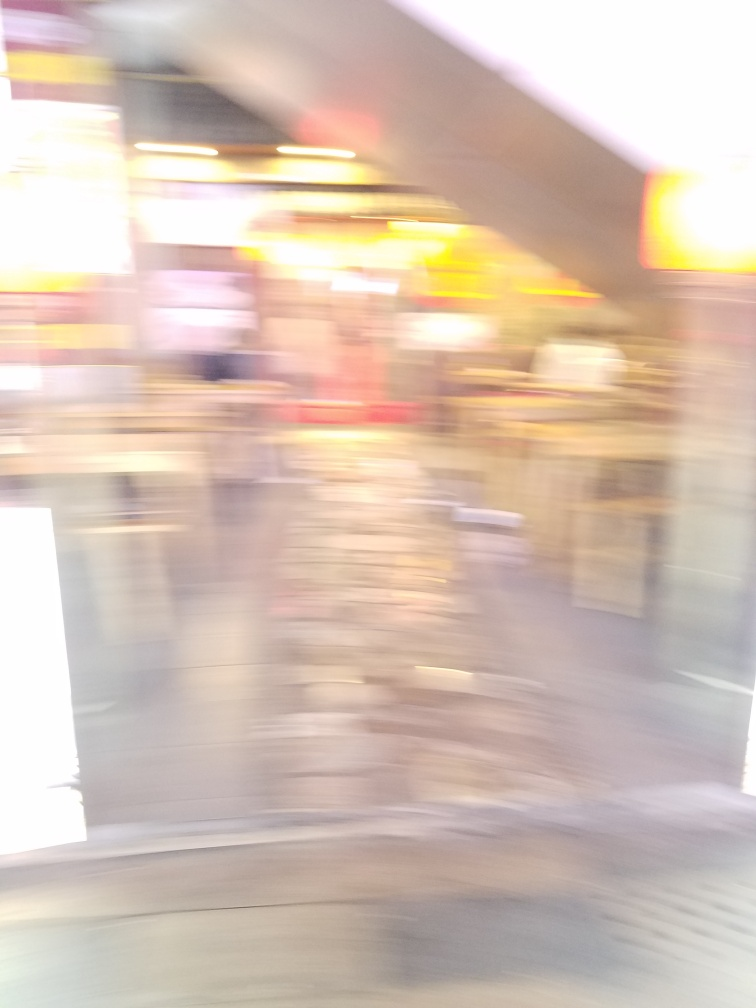Is there a lack of sharpness in the image?
A. Yes
B. No
Answer with the option's letter from the given choices directly.
 A. 